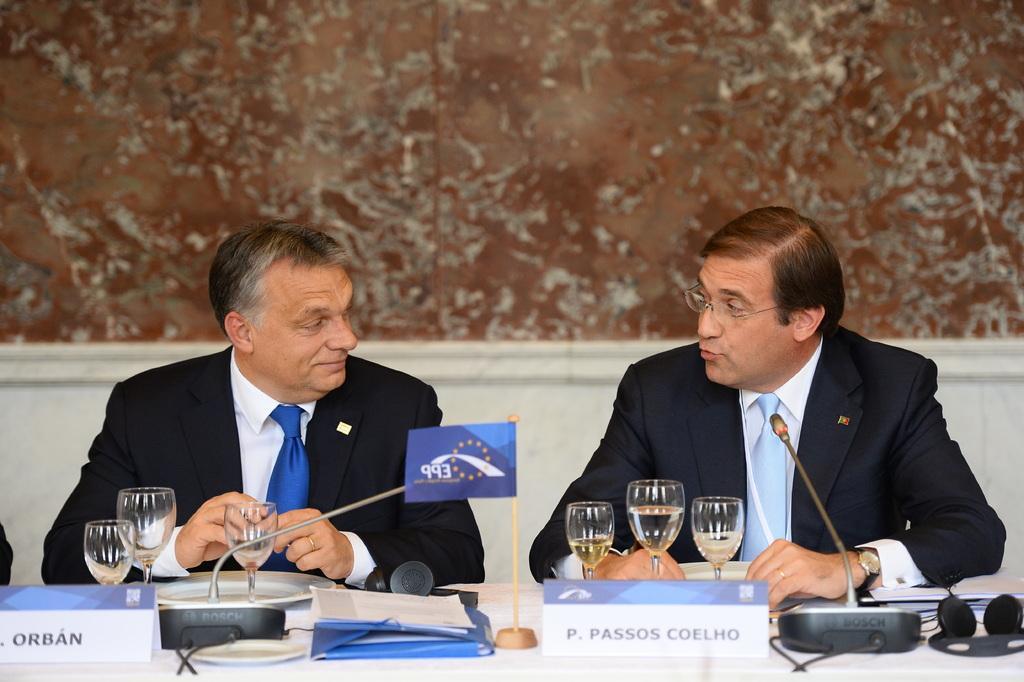Could you give a brief overview of what you see in this image? In this image we can see two persons are sitting, they are wearing a suit, in front there is a table, and glasses, plates, papers, and microphone on it, at the back there is a wall. 